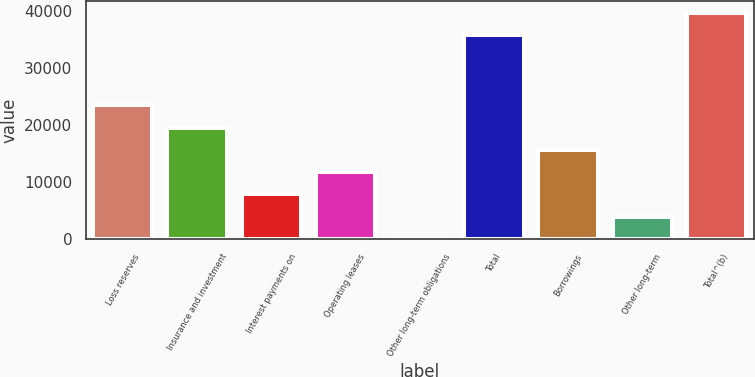<chart> <loc_0><loc_0><loc_500><loc_500><bar_chart><fcel>Loss reserves<fcel>Insurance and investment<fcel>Interest payments on<fcel>Operating leases<fcel>Other long-term obligations<fcel>Total<fcel>Borrowings<fcel>Other long-term<fcel>Total^(b)<nl><fcel>23503.8<fcel>19587.5<fcel>7838.6<fcel>11754.9<fcel>6<fcel>35860<fcel>15671.2<fcel>3922.3<fcel>39776.3<nl></chart> 